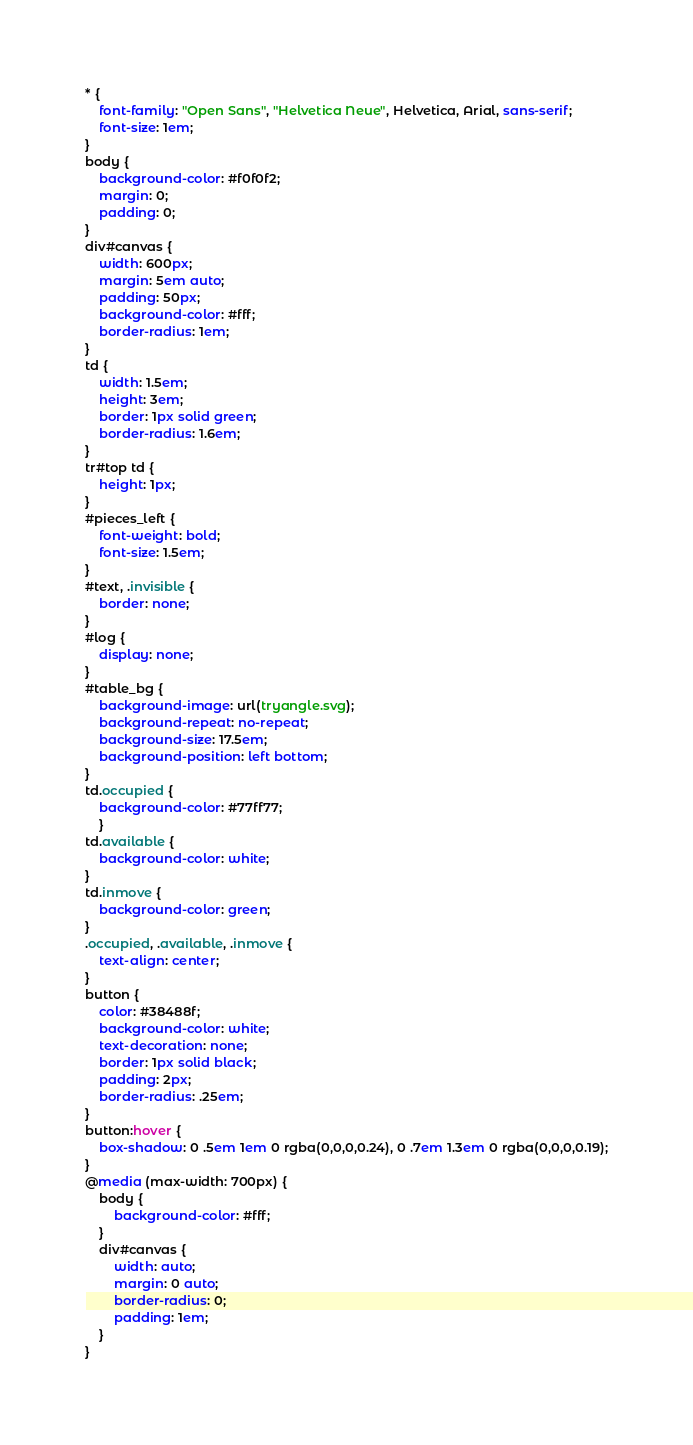Convert code to text. <code><loc_0><loc_0><loc_500><loc_500><_CSS_>* {
    font-family: "Open Sans", "Helvetica Neue", Helvetica, Arial, sans-serif;
    font-size: 1em;
}
body {
    background-color: #f0f0f2;
    margin: 0;
    padding: 0;
}
div#canvas {
    width: 600px;
    margin: 5em auto;
    padding: 50px;
    background-color: #fff;
    border-radius: 1em;
}
td {
    width: 1.5em;
    height: 3em;
    border: 1px solid green;
    border-radius: 1.6em;
}
tr#top td {
    height: 1px;
}
#pieces_left {
    font-weight: bold;
    font-size: 1.5em;
}
#text, .invisible {
    border: none;
}
#log {
    display: none;
}
#table_bg {
    background-image: url(tryangle.svg);
    background-repeat: no-repeat;
    background-size: 17.5em;
    background-position: left bottom;
}
td.occupied {
    background-color: #77ff77;
    }
td.available {
    background-color: white;
}
td.inmove {
    background-color: green;
}
.occupied, .available, .inmove {
    text-align: center;
}
button {
    color: #38488f;
    background-color: white;
    text-decoration: none;
    border: 1px solid black;
    padding: 2px;
    border-radius: .25em;
}
button:hover {
    box-shadow: 0 .5em 1em 0 rgba(0,0,0,0.24), 0 .7em 1.3em 0 rgba(0,0,0,0.19);
}
@media (max-width: 700px) {
    body {
        background-color: #fff;
    }
    div#canvas {
        width: auto;
        margin: 0 auto;
        border-radius: 0;
        padding: 1em;
    }
}</code> 